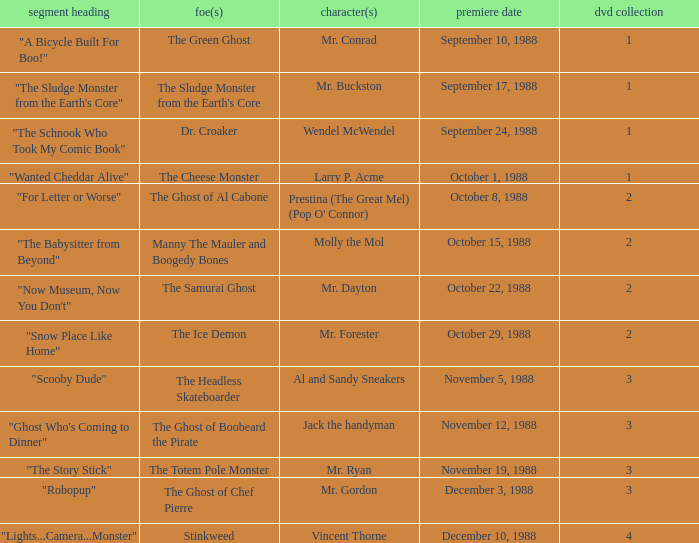Name the episode that aired october 8, 1988 "For Letter or Worse". 